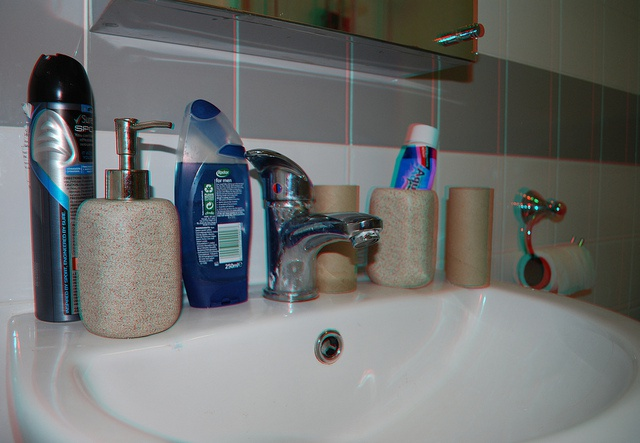Describe the objects in this image and their specific colors. I can see sink in gray and darkgray tones, bottle in gray and darkgray tones, bottle in gray, black, blue, and darkblue tones, bottle in gray, navy, black, and blue tones, and cup in gray tones in this image. 